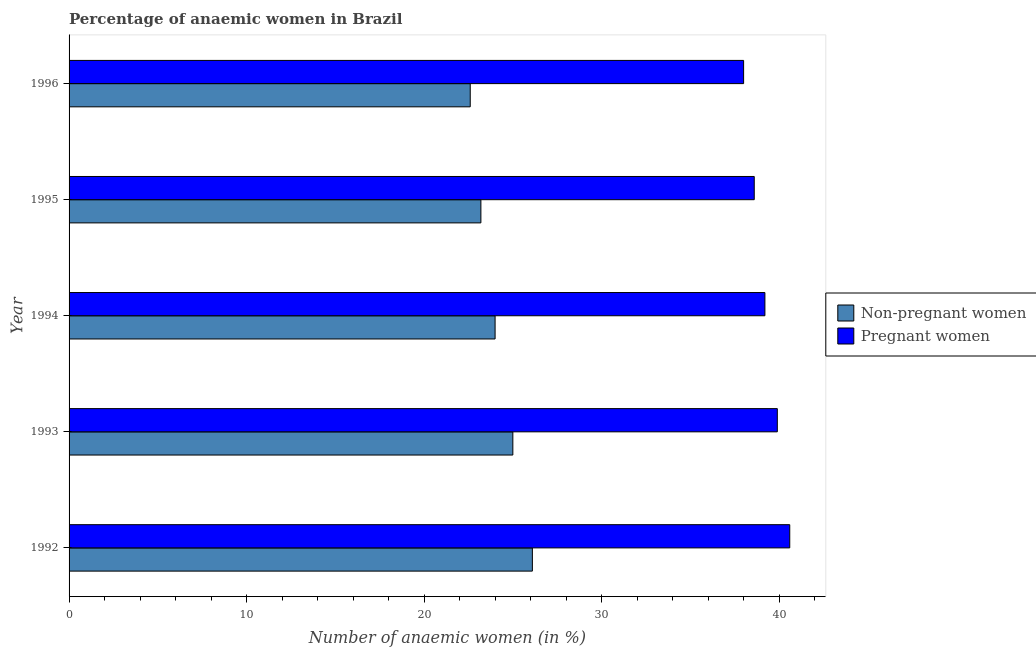How many different coloured bars are there?
Your answer should be compact. 2. How many groups of bars are there?
Ensure brevity in your answer.  5. Are the number of bars per tick equal to the number of legend labels?
Provide a succinct answer. Yes. How many bars are there on the 3rd tick from the bottom?
Your response must be concise. 2. What is the percentage of pregnant anaemic women in 1995?
Provide a succinct answer. 38.6. Across all years, what is the maximum percentage of non-pregnant anaemic women?
Your response must be concise. 26.1. Across all years, what is the minimum percentage of non-pregnant anaemic women?
Offer a very short reply. 22.6. In which year was the percentage of pregnant anaemic women minimum?
Your response must be concise. 1996. What is the total percentage of pregnant anaemic women in the graph?
Provide a succinct answer. 196.3. What is the difference between the percentage of non-pregnant anaemic women in 1994 and the percentage of pregnant anaemic women in 1995?
Offer a terse response. -14.6. What is the average percentage of pregnant anaemic women per year?
Offer a terse response. 39.26. What is the ratio of the percentage of pregnant anaemic women in 1994 to that in 1996?
Make the answer very short. 1.03. Is the percentage of pregnant anaemic women in 1992 less than that in 1995?
Give a very brief answer. No. What is the difference between the highest and the second highest percentage of pregnant anaemic women?
Keep it short and to the point. 0.7. Is the sum of the percentage of pregnant anaemic women in 1994 and 1996 greater than the maximum percentage of non-pregnant anaemic women across all years?
Provide a short and direct response. Yes. What does the 2nd bar from the top in 1993 represents?
Ensure brevity in your answer.  Non-pregnant women. What does the 2nd bar from the bottom in 1994 represents?
Give a very brief answer. Pregnant women. How many bars are there?
Keep it short and to the point. 10. Are all the bars in the graph horizontal?
Ensure brevity in your answer.  Yes. How many years are there in the graph?
Offer a terse response. 5. What is the difference between two consecutive major ticks on the X-axis?
Your answer should be compact. 10. Are the values on the major ticks of X-axis written in scientific E-notation?
Offer a very short reply. No. Does the graph contain any zero values?
Offer a terse response. No. Does the graph contain grids?
Give a very brief answer. No. How many legend labels are there?
Give a very brief answer. 2. How are the legend labels stacked?
Make the answer very short. Vertical. What is the title of the graph?
Provide a succinct answer. Percentage of anaemic women in Brazil. Does "Females" appear as one of the legend labels in the graph?
Keep it short and to the point. No. What is the label or title of the X-axis?
Give a very brief answer. Number of anaemic women (in %). What is the label or title of the Y-axis?
Offer a terse response. Year. What is the Number of anaemic women (in %) of Non-pregnant women in 1992?
Your response must be concise. 26.1. What is the Number of anaemic women (in %) in Pregnant women in 1992?
Your answer should be compact. 40.6. What is the Number of anaemic women (in %) of Non-pregnant women in 1993?
Your answer should be very brief. 25. What is the Number of anaemic women (in %) in Pregnant women in 1993?
Offer a terse response. 39.9. What is the Number of anaemic women (in %) of Pregnant women in 1994?
Your answer should be compact. 39.2. What is the Number of anaemic women (in %) of Non-pregnant women in 1995?
Offer a terse response. 23.2. What is the Number of anaemic women (in %) in Pregnant women in 1995?
Give a very brief answer. 38.6. What is the Number of anaemic women (in %) in Non-pregnant women in 1996?
Offer a terse response. 22.6. Across all years, what is the maximum Number of anaemic women (in %) of Non-pregnant women?
Provide a short and direct response. 26.1. Across all years, what is the maximum Number of anaemic women (in %) in Pregnant women?
Keep it short and to the point. 40.6. Across all years, what is the minimum Number of anaemic women (in %) in Non-pregnant women?
Your answer should be compact. 22.6. Across all years, what is the minimum Number of anaemic women (in %) of Pregnant women?
Your answer should be compact. 38. What is the total Number of anaemic women (in %) in Non-pregnant women in the graph?
Your answer should be very brief. 120.9. What is the total Number of anaemic women (in %) in Pregnant women in the graph?
Offer a very short reply. 196.3. What is the difference between the Number of anaemic women (in %) of Pregnant women in 1992 and that in 1994?
Your response must be concise. 1.4. What is the difference between the Number of anaemic women (in %) of Non-pregnant women in 1992 and that in 1995?
Keep it short and to the point. 2.9. What is the difference between the Number of anaemic women (in %) of Non-pregnant women in 1992 and that in 1996?
Keep it short and to the point. 3.5. What is the difference between the Number of anaemic women (in %) of Non-pregnant women in 1993 and that in 1995?
Your answer should be very brief. 1.8. What is the difference between the Number of anaemic women (in %) of Non-pregnant women in 1994 and that in 1996?
Offer a very short reply. 1.4. What is the difference between the Number of anaemic women (in %) of Pregnant women in 1994 and that in 1996?
Offer a terse response. 1.2. What is the difference between the Number of anaemic women (in %) of Pregnant women in 1995 and that in 1996?
Your answer should be very brief. 0.6. What is the difference between the Number of anaemic women (in %) of Non-pregnant women in 1993 and the Number of anaemic women (in %) of Pregnant women in 1994?
Offer a terse response. -14.2. What is the difference between the Number of anaemic women (in %) in Non-pregnant women in 1993 and the Number of anaemic women (in %) in Pregnant women in 1995?
Your answer should be very brief. -13.6. What is the difference between the Number of anaemic women (in %) of Non-pregnant women in 1993 and the Number of anaemic women (in %) of Pregnant women in 1996?
Give a very brief answer. -13. What is the difference between the Number of anaemic women (in %) of Non-pregnant women in 1994 and the Number of anaemic women (in %) of Pregnant women in 1995?
Your answer should be very brief. -14.6. What is the difference between the Number of anaemic women (in %) of Non-pregnant women in 1995 and the Number of anaemic women (in %) of Pregnant women in 1996?
Offer a very short reply. -14.8. What is the average Number of anaemic women (in %) in Non-pregnant women per year?
Offer a very short reply. 24.18. What is the average Number of anaemic women (in %) of Pregnant women per year?
Provide a short and direct response. 39.26. In the year 1992, what is the difference between the Number of anaemic women (in %) of Non-pregnant women and Number of anaemic women (in %) of Pregnant women?
Offer a very short reply. -14.5. In the year 1993, what is the difference between the Number of anaemic women (in %) of Non-pregnant women and Number of anaemic women (in %) of Pregnant women?
Your response must be concise. -14.9. In the year 1994, what is the difference between the Number of anaemic women (in %) of Non-pregnant women and Number of anaemic women (in %) of Pregnant women?
Provide a succinct answer. -15.2. In the year 1995, what is the difference between the Number of anaemic women (in %) of Non-pregnant women and Number of anaemic women (in %) of Pregnant women?
Your response must be concise. -15.4. In the year 1996, what is the difference between the Number of anaemic women (in %) of Non-pregnant women and Number of anaemic women (in %) of Pregnant women?
Give a very brief answer. -15.4. What is the ratio of the Number of anaemic women (in %) of Non-pregnant women in 1992 to that in 1993?
Offer a terse response. 1.04. What is the ratio of the Number of anaemic women (in %) in Pregnant women in 1992 to that in 1993?
Your response must be concise. 1.02. What is the ratio of the Number of anaemic women (in %) of Non-pregnant women in 1992 to that in 1994?
Ensure brevity in your answer.  1.09. What is the ratio of the Number of anaemic women (in %) in Pregnant women in 1992 to that in 1994?
Provide a short and direct response. 1.04. What is the ratio of the Number of anaemic women (in %) in Pregnant women in 1992 to that in 1995?
Offer a terse response. 1.05. What is the ratio of the Number of anaemic women (in %) in Non-pregnant women in 1992 to that in 1996?
Offer a very short reply. 1.15. What is the ratio of the Number of anaemic women (in %) of Pregnant women in 1992 to that in 1996?
Your answer should be very brief. 1.07. What is the ratio of the Number of anaemic women (in %) in Non-pregnant women in 1993 to that in 1994?
Make the answer very short. 1.04. What is the ratio of the Number of anaemic women (in %) of Pregnant women in 1993 to that in 1994?
Ensure brevity in your answer.  1.02. What is the ratio of the Number of anaemic women (in %) of Non-pregnant women in 1993 to that in 1995?
Make the answer very short. 1.08. What is the ratio of the Number of anaemic women (in %) of Pregnant women in 1993 to that in 1995?
Offer a terse response. 1.03. What is the ratio of the Number of anaemic women (in %) of Non-pregnant women in 1993 to that in 1996?
Make the answer very short. 1.11. What is the ratio of the Number of anaemic women (in %) in Pregnant women in 1993 to that in 1996?
Make the answer very short. 1.05. What is the ratio of the Number of anaemic women (in %) in Non-pregnant women in 1994 to that in 1995?
Provide a short and direct response. 1.03. What is the ratio of the Number of anaemic women (in %) of Pregnant women in 1994 to that in 1995?
Provide a short and direct response. 1.02. What is the ratio of the Number of anaemic women (in %) of Non-pregnant women in 1994 to that in 1996?
Your answer should be very brief. 1.06. What is the ratio of the Number of anaemic women (in %) in Pregnant women in 1994 to that in 1996?
Give a very brief answer. 1.03. What is the ratio of the Number of anaemic women (in %) of Non-pregnant women in 1995 to that in 1996?
Offer a very short reply. 1.03. What is the ratio of the Number of anaemic women (in %) of Pregnant women in 1995 to that in 1996?
Your answer should be compact. 1.02. What is the difference between the highest and the second highest Number of anaemic women (in %) of Non-pregnant women?
Your answer should be compact. 1.1. What is the difference between the highest and the second highest Number of anaemic women (in %) of Pregnant women?
Keep it short and to the point. 0.7. What is the difference between the highest and the lowest Number of anaemic women (in %) in Non-pregnant women?
Your answer should be very brief. 3.5. What is the difference between the highest and the lowest Number of anaemic women (in %) of Pregnant women?
Provide a succinct answer. 2.6. 